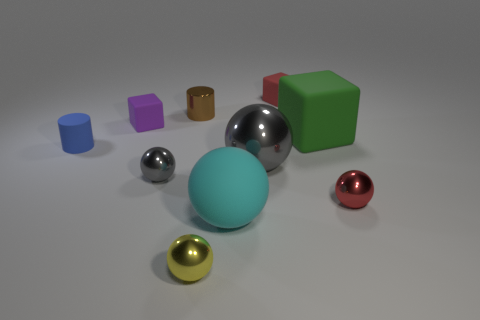There is a rubber object that is to the right of the red matte cube; what is its shape?
Provide a short and direct response. Cube. What is the color of the shiny sphere to the left of the yellow ball that is in front of the purple matte block?
Provide a short and direct response. Gray. How many objects are either tiny balls to the left of the big cyan rubber ball or small gray objects?
Make the answer very short. 2. There is a purple rubber cube; is its size the same as the thing that is on the right side of the big green block?
Give a very brief answer. Yes. How many big objects are either shiny objects or red rubber things?
Provide a succinct answer. 1. There is a tiny gray metal object; what shape is it?
Provide a short and direct response. Sphere. Are there any blue cylinders made of the same material as the big green cube?
Provide a succinct answer. Yes. Are there more green matte cylinders than shiny balls?
Keep it short and to the point. No. Are the tiny yellow thing and the tiny brown cylinder made of the same material?
Ensure brevity in your answer.  Yes. What number of rubber things are either small purple things or red blocks?
Provide a short and direct response. 2. 